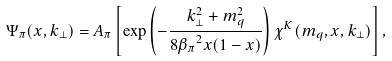Convert formula to latex. <formula><loc_0><loc_0><loc_500><loc_500>\Psi _ { \pi } ( x , { k } _ { \perp } ) = A _ { \pi } \left [ \exp \left ( - \frac { { k } _ { \perp } ^ { 2 } + m _ { q } ^ { 2 } } { 8 { \beta _ { \pi } } ^ { 2 } x ( 1 - x ) } \right ) \chi ^ { K } ( m _ { q } , x , { k } _ { \perp } ) \right ] ,</formula> 